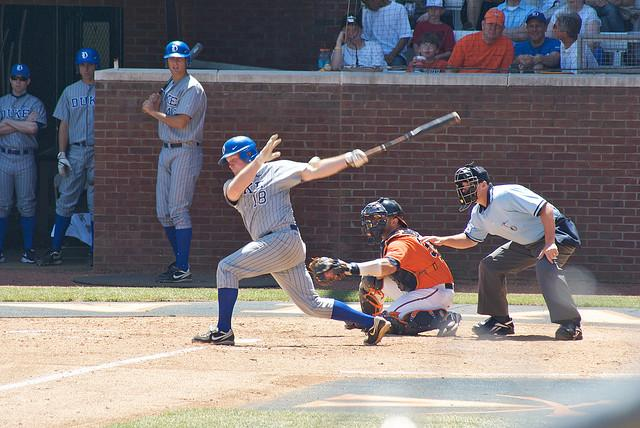What baseball player has the same first name as the name on the player all the way to the left's jersey?

Choices:
A) duke snider
B) jim kaat
C) alabama al
D) stanford napoli duke snider 